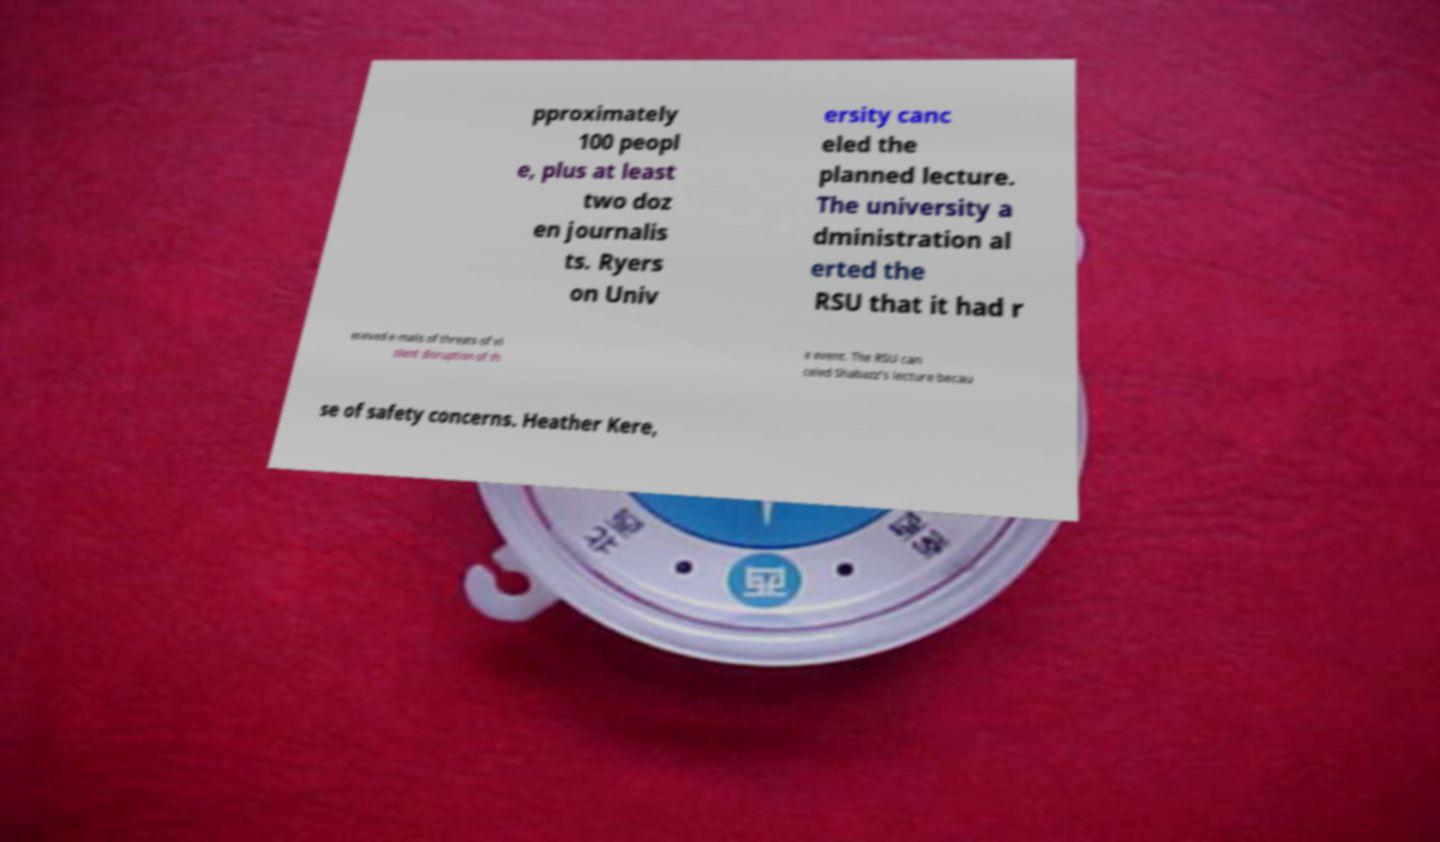Please identify and transcribe the text found in this image. pproximately 100 peopl e, plus at least two doz en journalis ts. Ryers on Univ ersity canc eled the planned lecture. The university a dministration al erted the RSU that it had r eceived e-mails of threats of vi olent disruption of th e event. The RSU can celed Shabazz's lecture becau se of safety concerns. Heather Kere, 